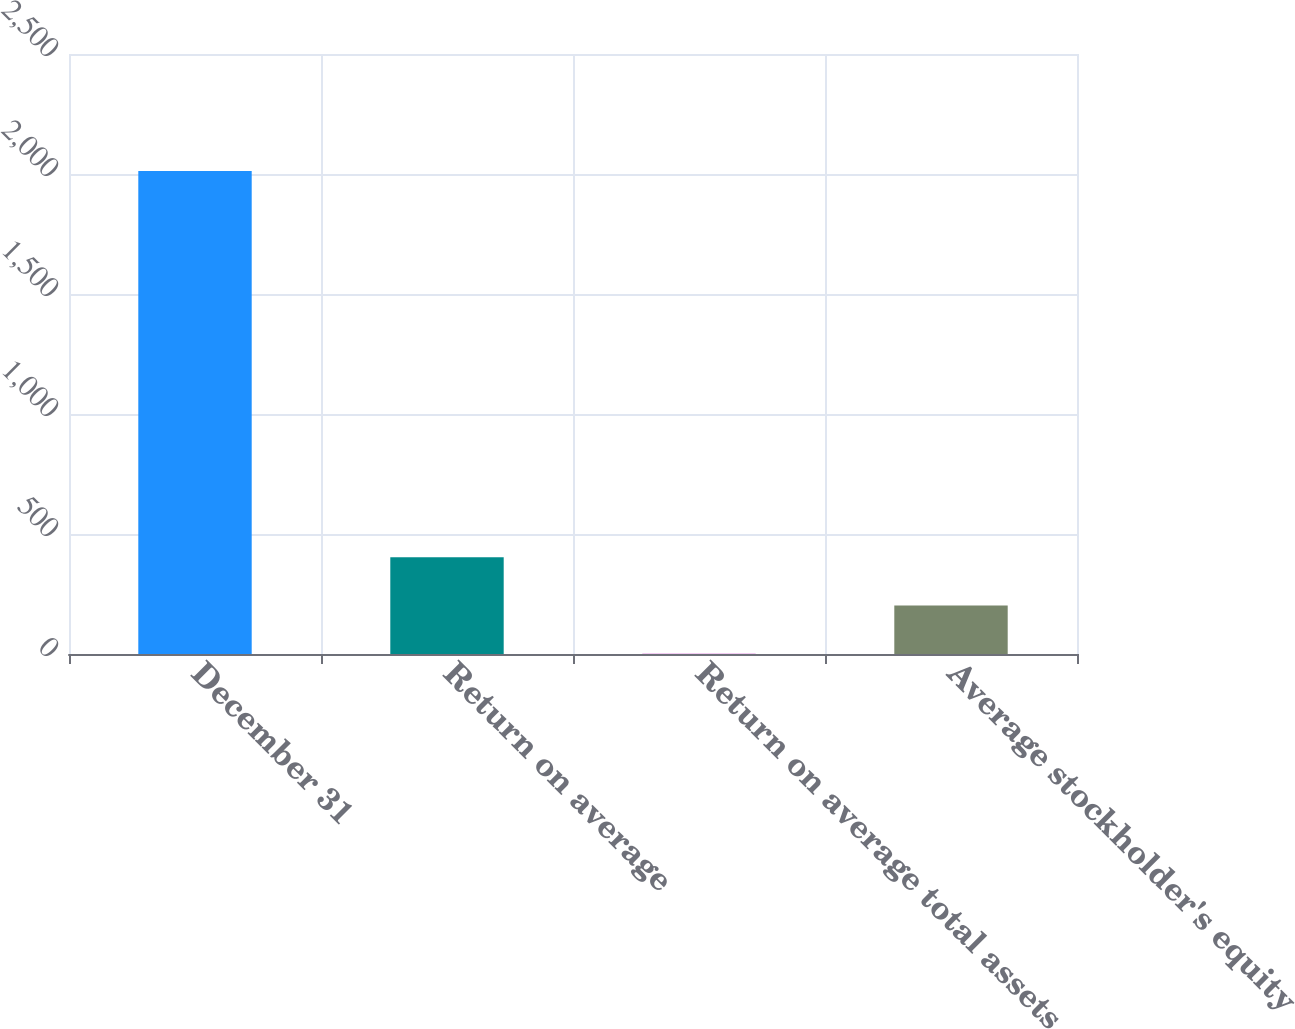<chart> <loc_0><loc_0><loc_500><loc_500><bar_chart><fcel>December 31<fcel>Return on average<fcel>Return on average total assets<fcel>Average stockholder's equity<nl><fcel>2013<fcel>403.29<fcel>0.85<fcel>202.07<nl></chart> 